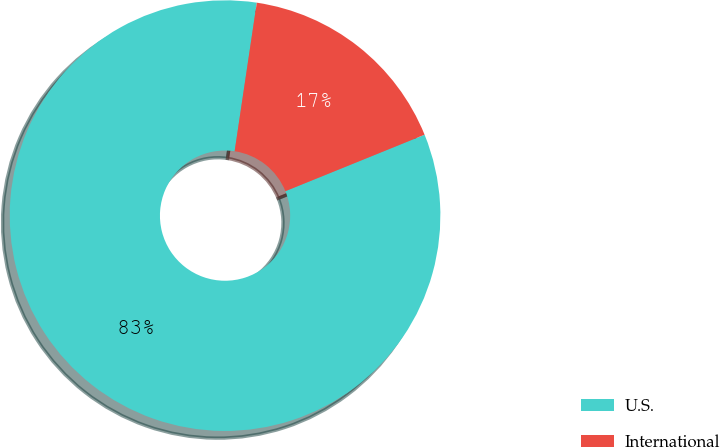Convert chart. <chart><loc_0><loc_0><loc_500><loc_500><pie_chart><fcel>U.S.<fcel>International<nl><fcel>83.49%<fcel>16.51%<nl></chart> 